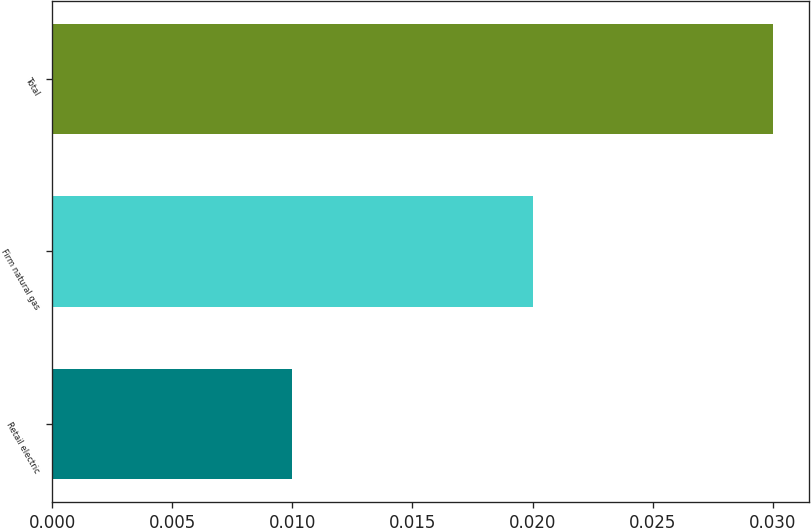Convert chart. <chart><loc_0><loc_0><loc_500><loc_500><bar_chart><fcel>Retail electric<fcel>Firm natural gas<fcel>Total<nl><fcel>0.01<fcel>0.02<fcel>0.03<nl></chart> 